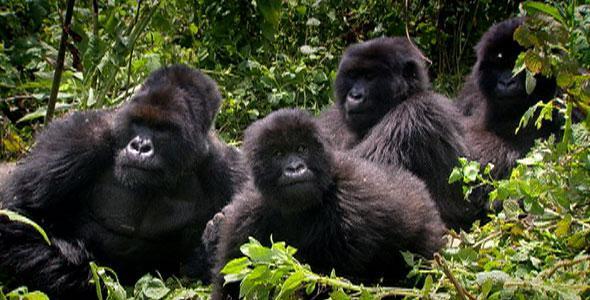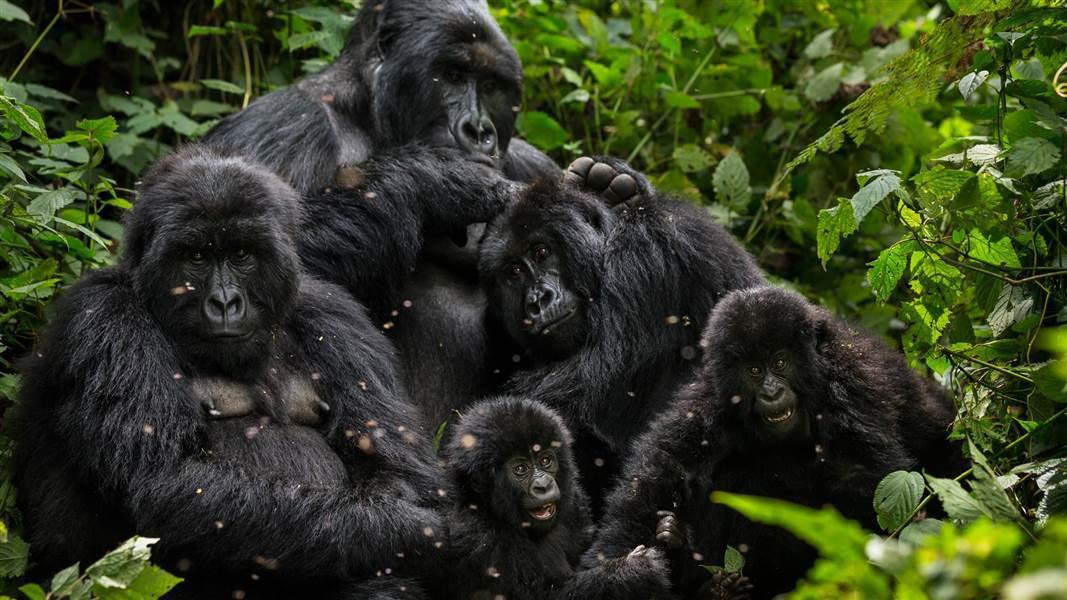The first image is the image on the left, the second image is the image on the right. Evaluate the accuracy of this statement regarding the images: "None of the apes are carrying a baby.". Is it true? Answer yes or no. Yes. The first image is the image on the left, the second image is the image on the right. Examine the images to the left and right. Is the description "An image contains a single gorilla with brown eyes and soft-looking hair." accurate? Answer yes or no. No. 